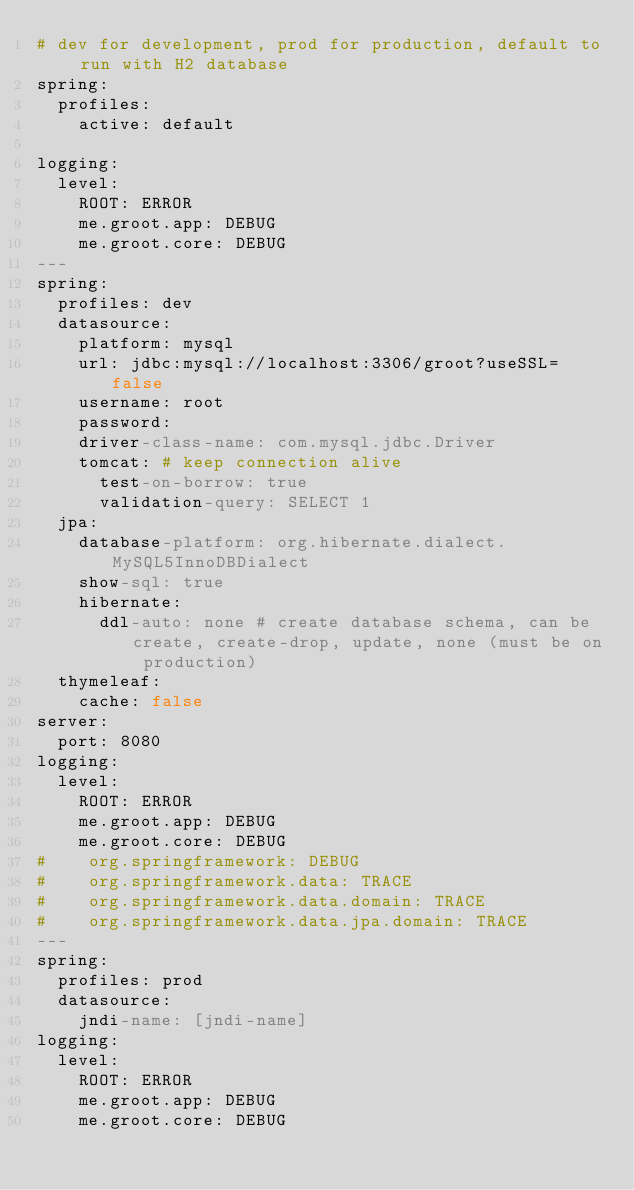Convert code to text. <code><loc_0><loc_0><loc_500><loc_500><_YAML_># dev for development, prod for production, default to run with H2 database
spring:
  profiles:
    active: default

logging:
  level:
    ROOT: ERROR
    me.groot.app: DEBUG
    me.groot.core: DEBUG
---
spring:
  profiles: dev
  datasource:
    platform: mysql
    url: jdbc:mysql://localhost:3306/groot?useSSL=false
    username: root
    password:
    driver-class-name: com.mysql.jdbc.Driver
    tomcat: # keep connection alive
      test-on-borrow: true
      validation-query: SELECT 1
  jpa:
    database-platform: org.hibernate.dialect.MySQL5InnoDBDialect
    show-sql: true
    hibernate:
      ddl-auto: none # create database schema, can be create, create-drop, update, none (must be on production)
  thymeleaf:
    cache: false
server:
  port: 8080
logging:
  level:
    ROOT: ERROR
    me.groot.app: DEBUG
    me.groot.core: DEBUG
#    org.springframework: DEBUG
#    org.springframework.data: TRACE
#    org.springframework.data.domain: TRACE
#    org.springframework.data.jpa.domain: TRACE
---
spring:
  profiles: prod
  datasource:
    jndi-name: [jndi-name]
logging:
  level:
    ROOT: ERROR
    me.groot.app: DEBUG
    me.groot.core: DEBUG
</code> 